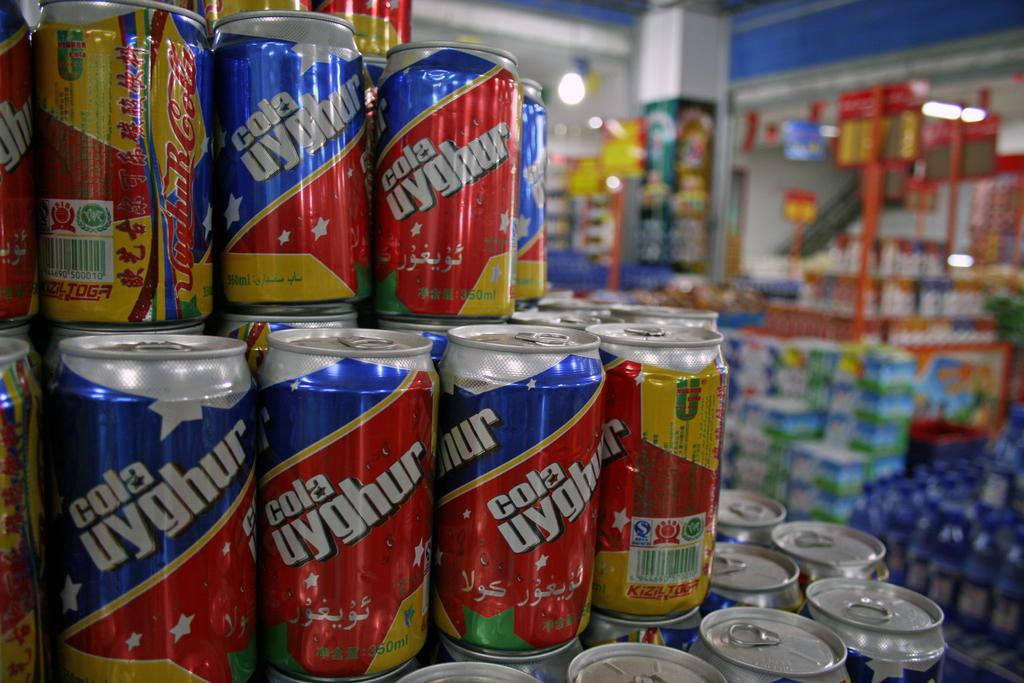<image>
Relay a brief, clear account of the picture shown. Many cans of uyghur cola are stacked up at the store. 